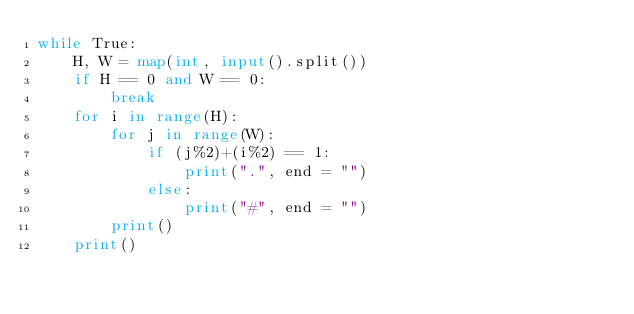Convert code to text. <code><loc_0><loc_0><loc_500><loc_500><_Python_>while True:
    H, W = map(int, input().split())
    if H == 0 and W == 0:
        break
    for i in range(H):
        for j in range(W):
            if (j%2)+(i%2) == 1:
                print(".", end = "")
            else:
                print("#", end = "")
        print()
    print()
</code> 